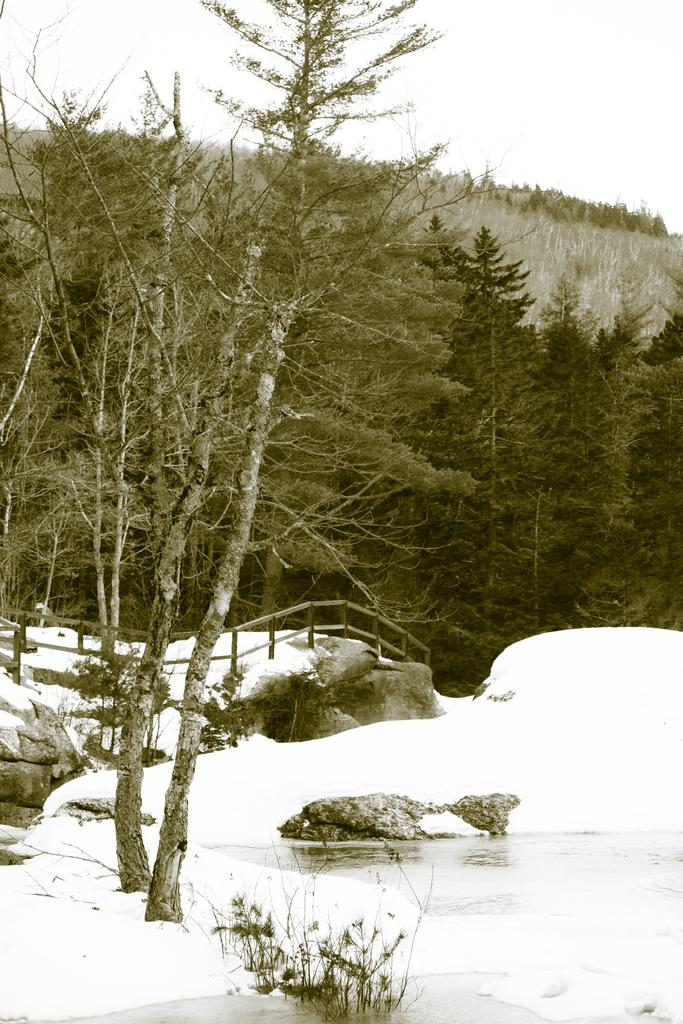What type of natural environment is depicted in the image? There are trees and water visible in the image, suggesting a natural environment. What type of structure is present in the image? It appears to be a foot over bridge in the image. What is the weather like in the image? The sky is cloudy in the image. Is there any snow present in the image? Yes, there is snow in the image. Can you see a house in the image? There is no house present in the image. Is there a rifle visible in the image? There is no rifle present in the image. 